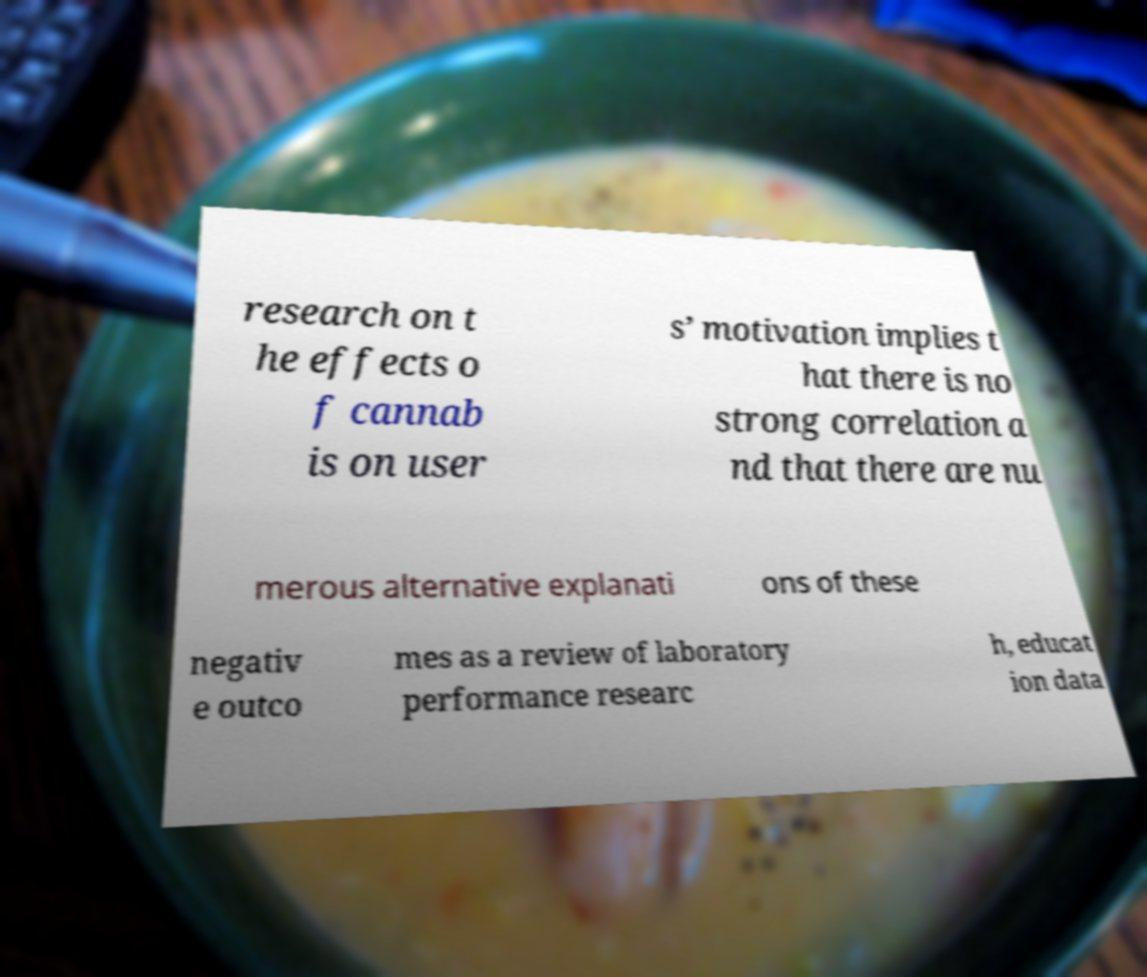Could you assist in decoding the text presented in this image and type it out clearly? research on t he effects o f cannab is on user s’ motivation implies t hat there is no strong correlation a nd that there are nu merous alternative explanati ons of these negativ e outco mes as a review of laboratory performance researc h, educat ion data 